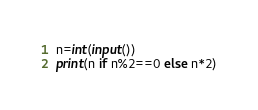<code> <loc_0><loc_0><loc_500><loc_500><_Python_>n=int(input())
print(n if n%2==0 else n*2)</code> 